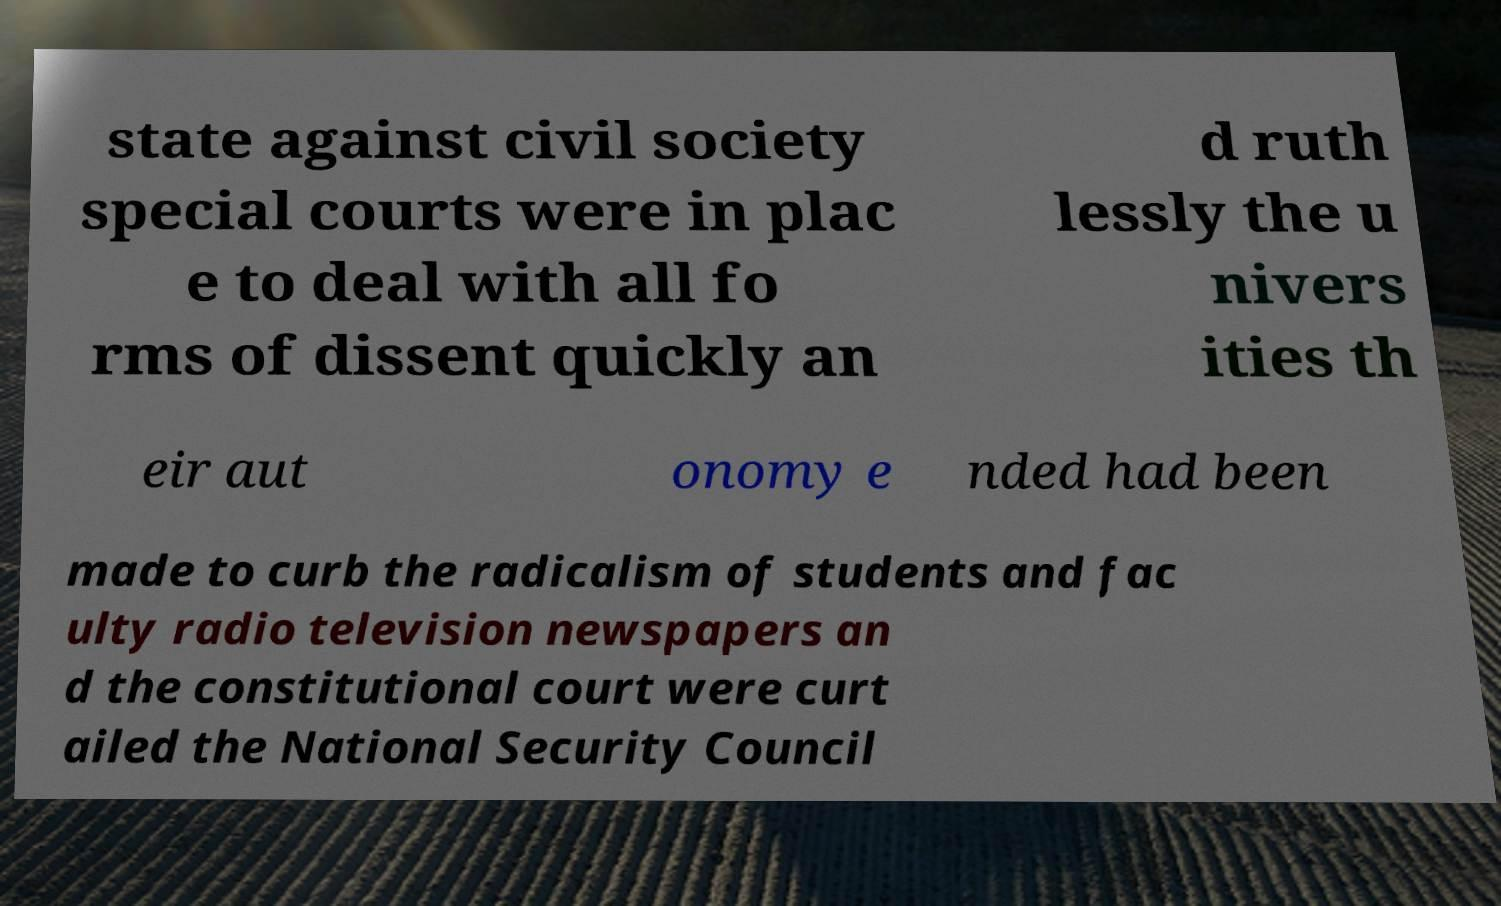For documentation purposes, I need the text within this image transcribed. Could you provide that? state against civil society special courts were in plac e to deal with all fo rms of dissent quickly an d ruth lessly the u nivers ities th eir aut onomy e nded had been made to curb the radicalism of students and fac ulty radio television newspapers an d the constitutional court were curt ailed the National Security Council 